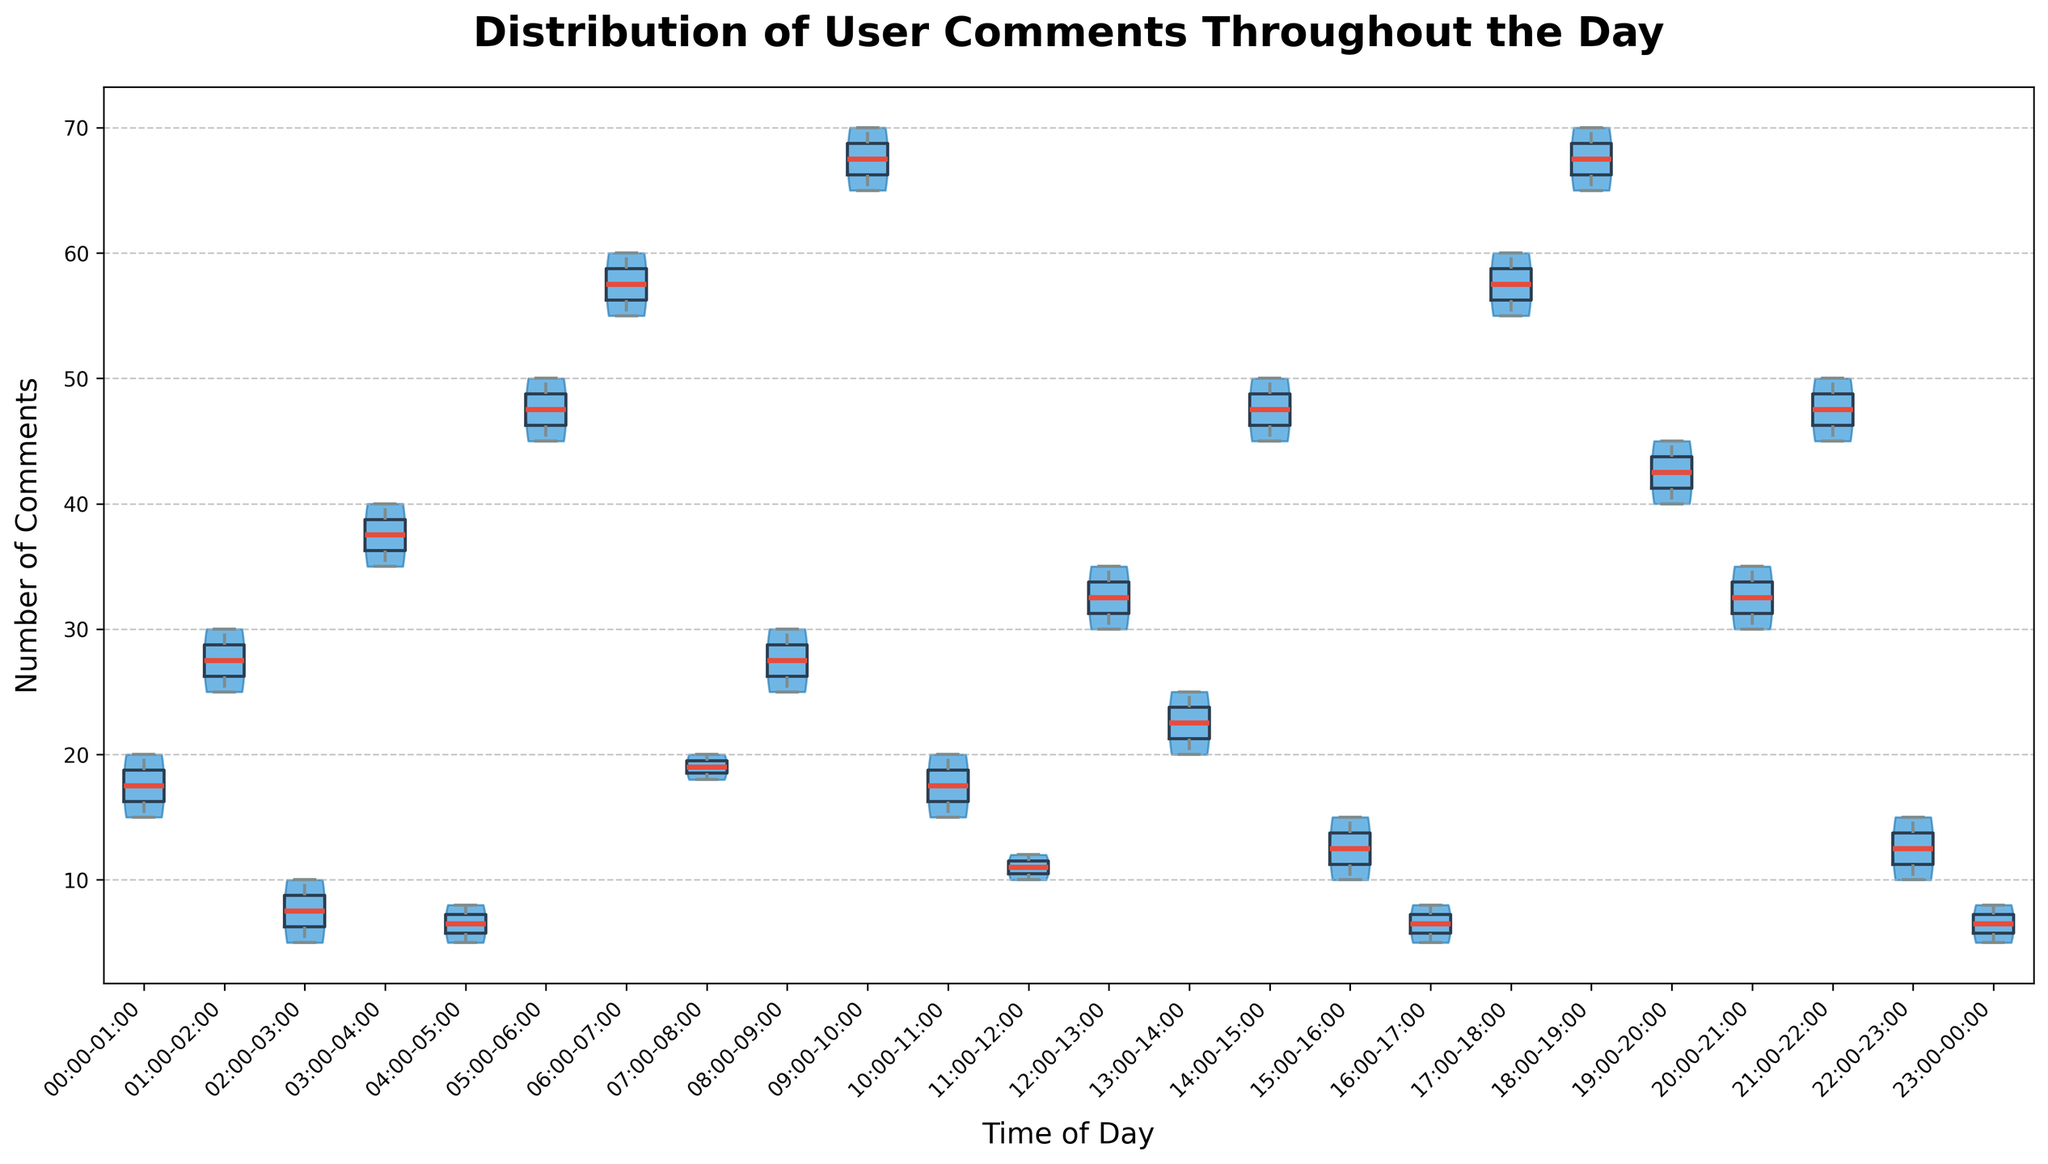What is the title of the figure? The title of the figure is displayed at the top in a larger, bold font.
Answer: Distribution of User Comments Throughout the Day What are the labels of the x-axis and y-axis? The x-axis and y-axis labels are shown beneath and beside the figure, respectively. The x-axis label describes the times of day, and the y-axis label describes the number of comments.
Answer: Time of Day, Number of Comments Which time period shows the most concentrated distribution of comments? The violin plot shows the density of the comments at different times. The period with the most concentrated distribution will have the narrowest violin shape.
Answer: 02:00-03:00 What is the median number of comments during the period 09:00-10:00? Inside each violin plot, there are box plots showing median values. The median is represented by a line inside the box. For 09:00-10:00, observe the central line in the box plot.
Answer: 67.5 Which two periods have the largest spread of comments? Violin plots with wider shapes represent a larger spread of comments. Identify the two periods with the widest body shapes along the x-axis.
Answer: 06:00-07:00 and 18:00-19:00 How does the number of comments vary between the periods 00:00-01:00 and 12:00-13:00? Compare the shapes and spread of the violin plots for these two periods. 00:00-01:00 shows a narrower and lower spread than 12:00-13:00.
Answer: 12:00-13:00 has a higher and more varied number of comments than 00:00-01:00 Which time period exhibits the lowest median number of comments? The violin plot with the box plot line closest to the bottom on the y-axis indicates the lowest median number of comments.
Answer: 02:00-03:00 What is the range of comments during the period 06:00-07:00? The range can be observed by noting the highest and lowest whisker extensions in the box plot inside the violin plot for 06:00-07:00.
Answer: 55 to 60 How often do users comment between 18:00-19:00 compared to 03:00-04:00? The density and height of the violin plots indicate how the comments are distributed. Compare the two time periods directly.
Answer: Users comment more frequently between 18:00-19:00 than between 03:00-04:00 Which time period has a higher median: 14:00-15:00 or 20:00-21:00? Compare the central lines in the box plots for both periods. The time period with the higher median will have a higher central line.
Answer: 14:00-15:00 has a higher median than 20:00-21:00 